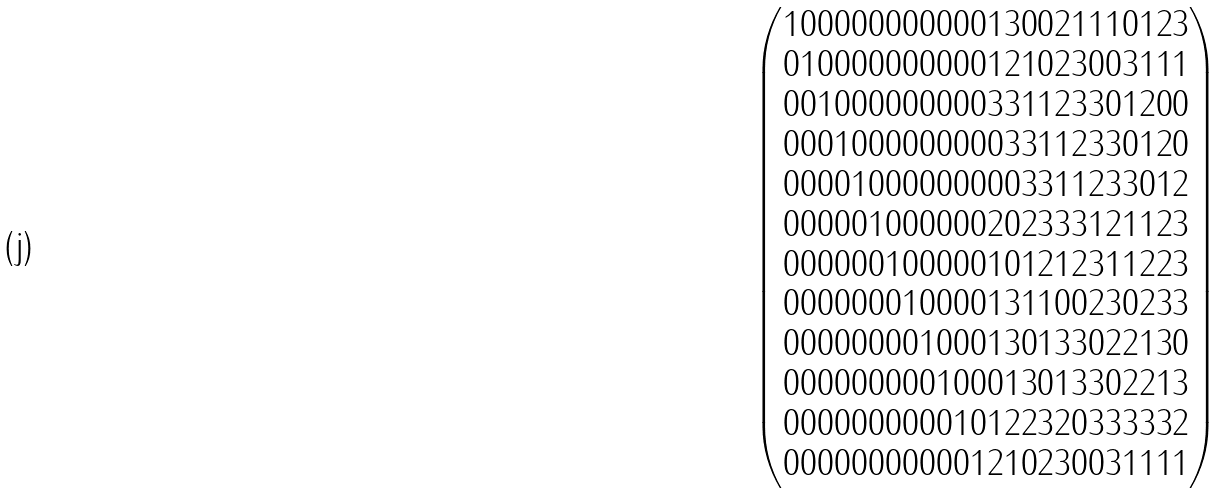Convert formula to latex. <formula><loc_0><loc_0><loc_500><loc_500>\begin{pmatrix} 1 0 0 0 0 0 0 0 0 0 0 0 1 3 0 0 2 1 1 1 0 1 2 3 \\ 0 1 0 0 0 0 0 0 0 0 0 0 1 2 1 0 2 3 0 0 3 1 1 1 \\ 0 0 1 0 0 0 0 0 0 0 0 0 3 3 1 1 2 3 3 0 1 2 0 0 \\ 0 0 0 1 0 0 0 0 0 0 0 0 0 3 3 1 1 2 3 3 0 1 2 0 \\ 0 0 0 0 1 0 0 0 0 0 0 0 0 0 3 3 1 1 2 3 3 0 1 2 \\ 0 0 0 0 0 1 0 0 0 0 0 0 2 0 2 3 3 3 1 2 1 1 2 3 \\ 0 0 0 0 0 0 1 0 0 0 0 0 1 0 1 2 1 2 3 1 1 2 2 3 \\ 0 0 0 0 0 0 0 1 0 0 0 0 1 3 1 1 0 0 2 3 0 2 3 3 \\ 0 0 0 0 0 0 0 0 1 0 0 0 1 3 0 1 3 3 0 2 2 1 3 0 \\ 0 0 0 0 0 0 0 0 0 1 0 0 0 1 3 0 1 3 3 0 2 2 1 3 \\ 0 0 0 0 0 0 0 0 0 0 1 0 1 2 2 3 2 0 3 3 3 3 3 2 \\ 0 0 0 0 0 0 0 0 0 0 0 1 2 1 0 2 3 0 0 3 1 1 1 1 \end{pmatrix}</formula> 